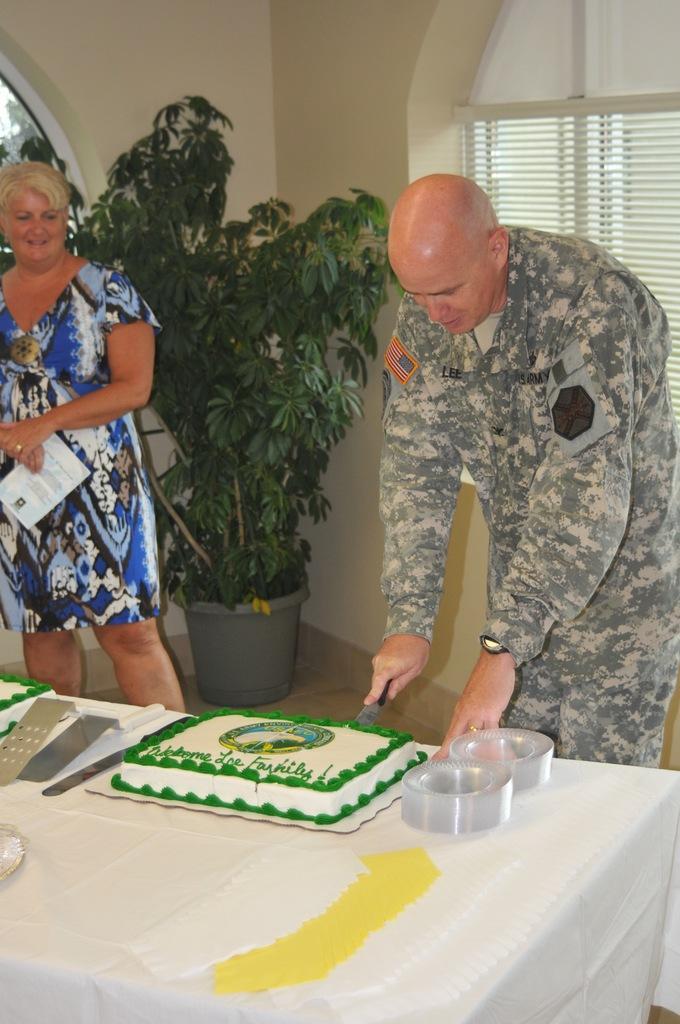Could you give a brief overview of what you see in this image? On the background we can see a window and a wall. A house plant on the floor. Here we can see a man standing near to the table , holding a knife in his hand and cutting a cake. We can see one woman standing beside to him and holding a paper in her hand and smiling. 